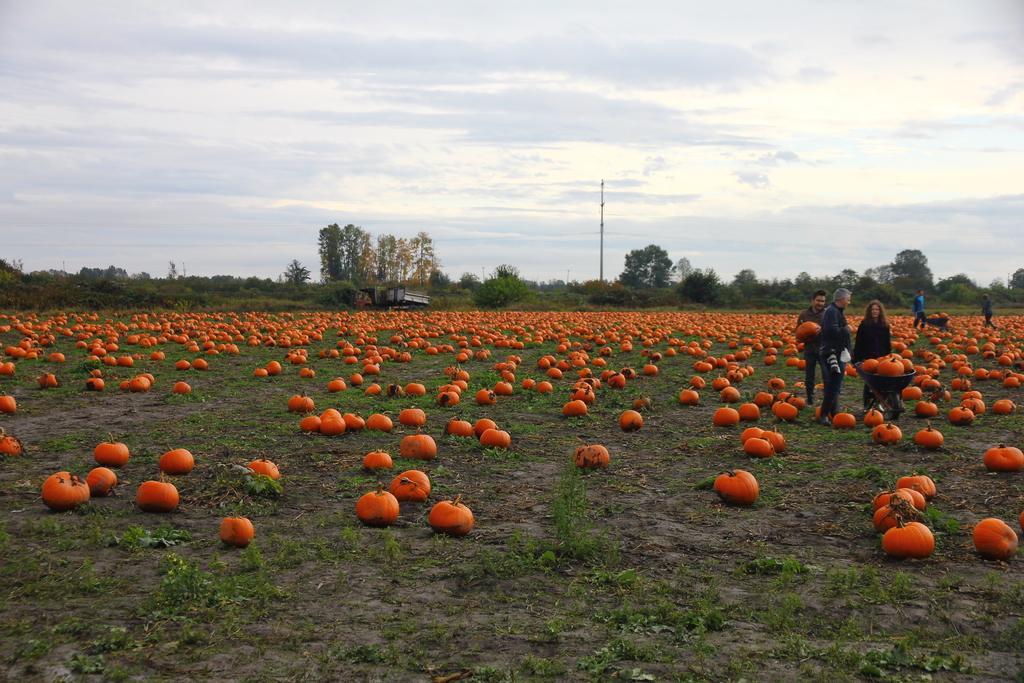Can you describe this image briefly? As we can see in the image there are pumpkins, few people, pole and in the background there are trees. At the top there is sky and clouds. 